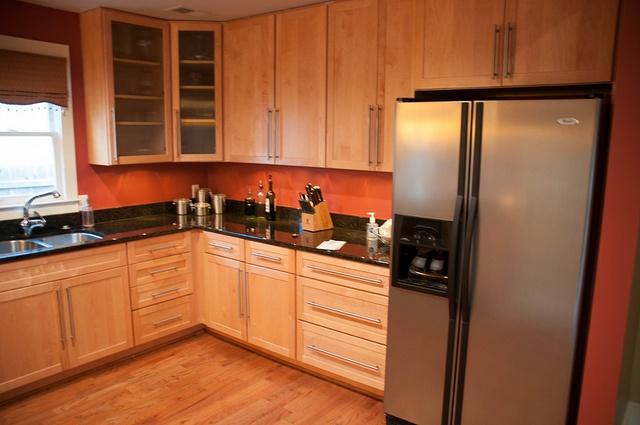Describe the objects in this image and their specific colors. I can see refrigerator in black, gray, and brown tones, sink in black, gray, and darkgray tones, bottle in black, maroon, and brown tones, bottle in black, maroon, and brown tones, and bowl in black, maroon, and tan tones in this image. 